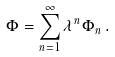<formula> <loc_0><loc_0><loc_500><loc_500>\Phi = \sum _ { n = 1 } ^ { \infty } \lambda ^ { n } \Phi _ { n } \, .</formula> 